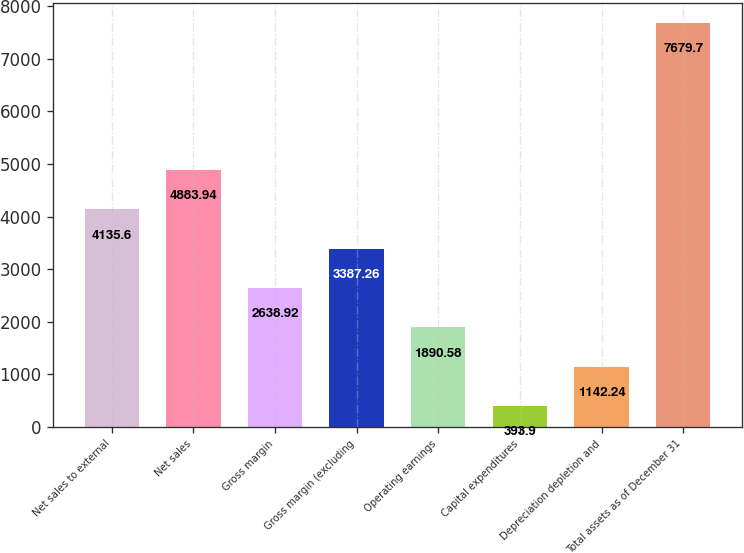Convert chart. <chart><loc_0><loc_0><loc_500><loc_500><bar_chart><fcel>Net sales to external<fcel>Net sales<fcel>Gross margin<fcel>Gross margin (excluding<fcel>Operating earnings<fcel>Capital expenditures<fcel>Depreciation depletion and<fcel>Total assets as of December 31<nl><fcel>4135.6<fcel>4883.94<fcel>2638.92<fcel>3387.26<fcel>1890.58<fcel>393.9<fcel>1142.24<fcel>7679.7<nl></chart> 